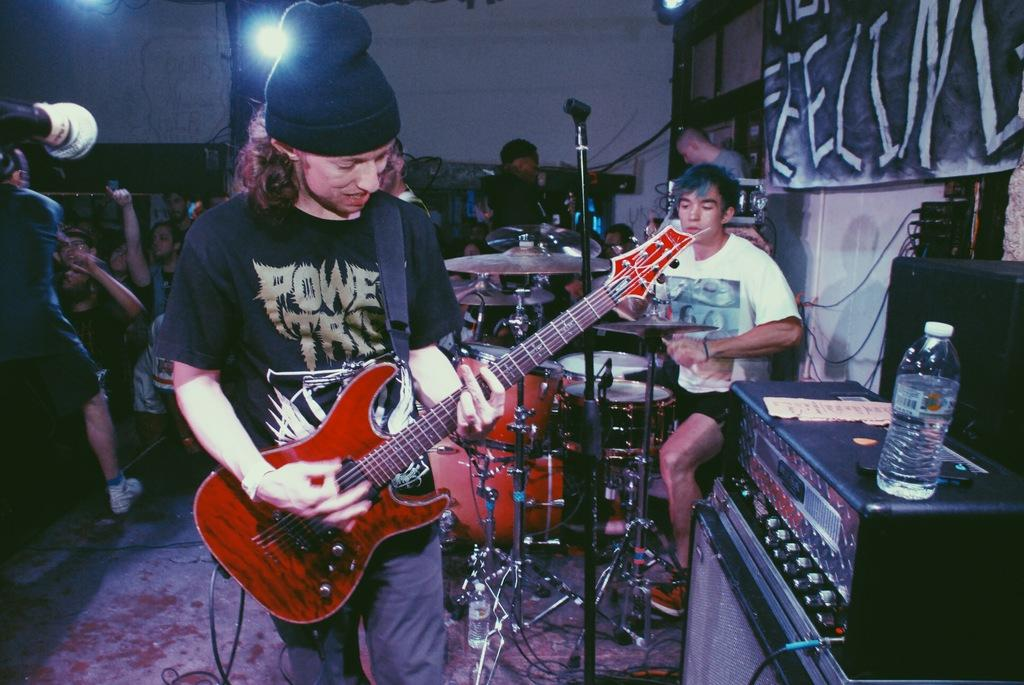Who is present in the image? There is a man in the image. What is the man doing in the image? The man is standing and holding a guitar in his hand. Are there any other people visible in the image? Yes, there are people standing in the background of the image. What type of fruit is the man eating during the meeting in the image? There is no fruit or meeting present in the image; the man is holding a guitar. 